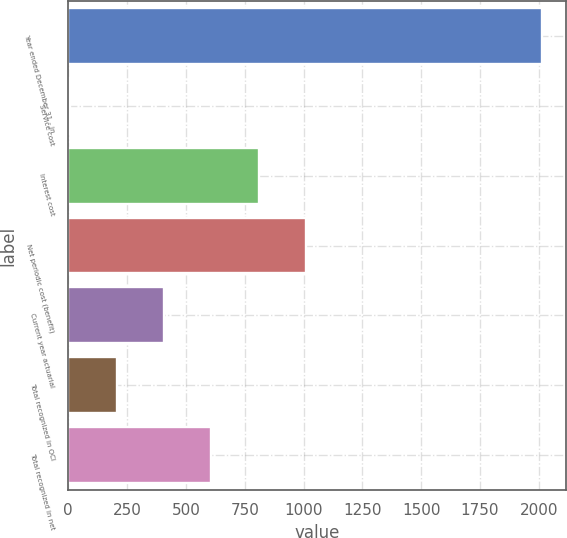<chart> <loc_0><loc_0><loc_500><loc_500><bar_chart><fcel>Year ended December 31 - in<fcel>Service cost<fcel>Interest cost<fcel>Net periodic cost (benefit)<fcel>Current year actuarial<fcel>Total recognized in OCI<fcel>Total recognized in net<nl><fcel>2013<fcel>6<fcel>808.8<fcel>1009.5<fcel>407.4<fcel>206.7<fcel>608.1<nl></chart> 